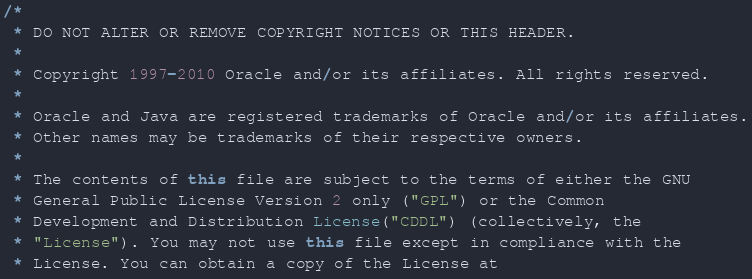Convert code to text. <code><loc_0><loc_0><loc_500><loc_500><_Java_>/*
 * DO NOT ALTER OR REMOVE COPYRIGHT NOTICES OR THIS HEADER.
 *
 * Copyright 1997-2010 Oracle and/or its affiliates. All rights reserved.
 *
 * Oracle and Java are registered trademarks of Oracle and/or its affiliates.
 * Other names may be trademarks of their respective owners.
 *
 * The contents of this file are subject to the terms of either the GNU
 * General Public License Version 2 only ("GPL") or the Common
 * Development and Distribution License("CDDL") (collectively, the
 * "License"). You may not use this file except in compliance with the
 * License. You can obtain a copy of the License at</code> 